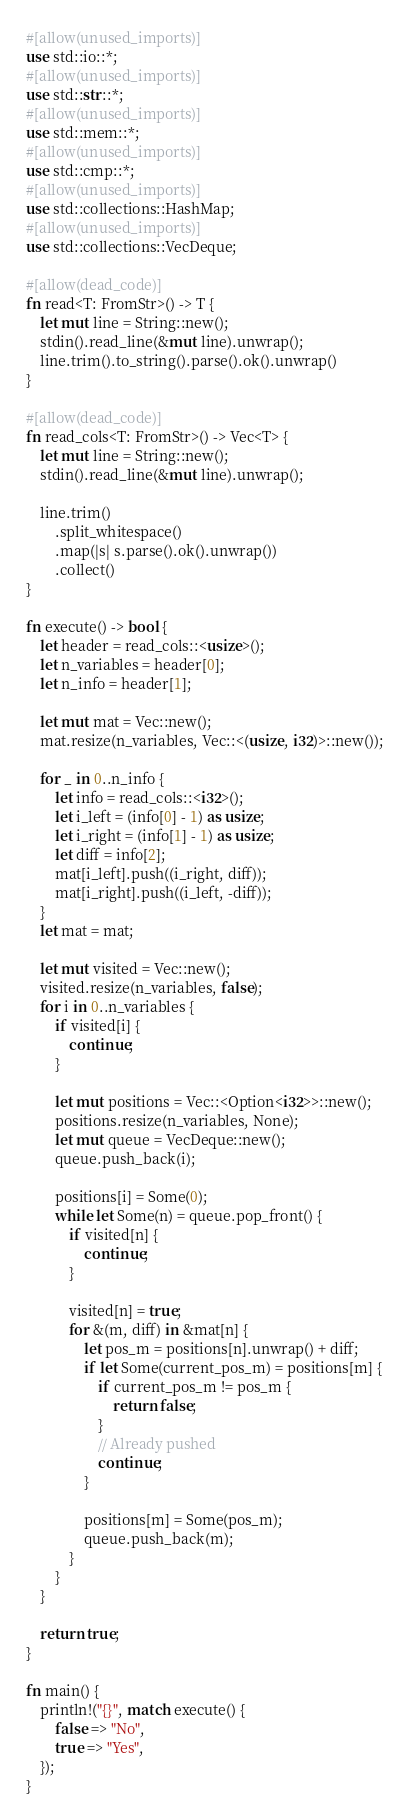Convert code to text. <code><loc_0><loc_0><loc_500><loc_500><_Rust_>#[allow(unused_imports)]
use std::io::*;
#[allow(unused_imports)]
use std::str::*;
#[allow(unused_imports)]
use std::mem::*;
#[allow(unused_imports)]
use std::cmp::*;
#[allow(unused_imports)]
use std::collections::HashMap;
#[allow(unused_imports)]
use std::collections::VecDeque;

#[allow(dead_code)]
fn read<T: FromStr>() -> T {
    let mut line = String::new();
    stdin().read_line(&mut line).unwrap();
    line.trim().to_string().parse().ok().unwrap()
}

#[allow(dead_code)]
fn read_cols<T: FromStr>() -> Vec<T> {
    let mut line = String::new();
    stdin().read_line(&mut line).unwrap();

    line.trim()
        .split_whitespace()
        .map(|s| s.parse().ok().unwrap())
        .collect()
}

fn execute() -> bool {
    let header = read_cols::<usize>();
    let n_variables = header[0];
    let n_info = header[1];

    let mut mat = Vec::new();
    mat.resize(n_variables, Vec::<(usize, i32)>::new());

    for _ in 0..n_info {
        let info = read_cols::<i32>();
        let i_left = (info[0] - 1) as usize;
        let i_right = (info[1] - 1) as usize;
        let diff = info[2];
        mat[i_left].push((i_right, diff));
        mat[i_right].push((i_left, -diff));
    }
    let mat = mat;

    let mut visited = Vec::new();
    visited.resize(n_variables, false);
    for i in 0..n_variables {
        if visited[i] {
            continue;
        }

        let mut positions = Vec::<Option<i32>>::new();
        positions.resize(n_variables, None);
        let mut queue = VecDeque::new();
        queue.push_back(i);

        positions[i] = Some(0);
        while let Some(n) = queue.pop_front() {
            if visited[n] {
                continue;
            }

            visited[n] = true;
            for &(m, diff) in &mat[n] {
                let pos_m = positions[n].unwrap() + diff;
                if let Some(current_pos_m) = positions[m] {
                    if current_pos_m != pos_m {
                        return false;
                    }
                    // Already pushed
                    continue;
                }

                positions[m] = Some(pos_m);
                queue.push_back(m);
            }
        }
    }

    return true;
}

fn main() {
    println!("{}", match execute() {
        false => "No",
        true => "Yes",
    });
}
</code> 